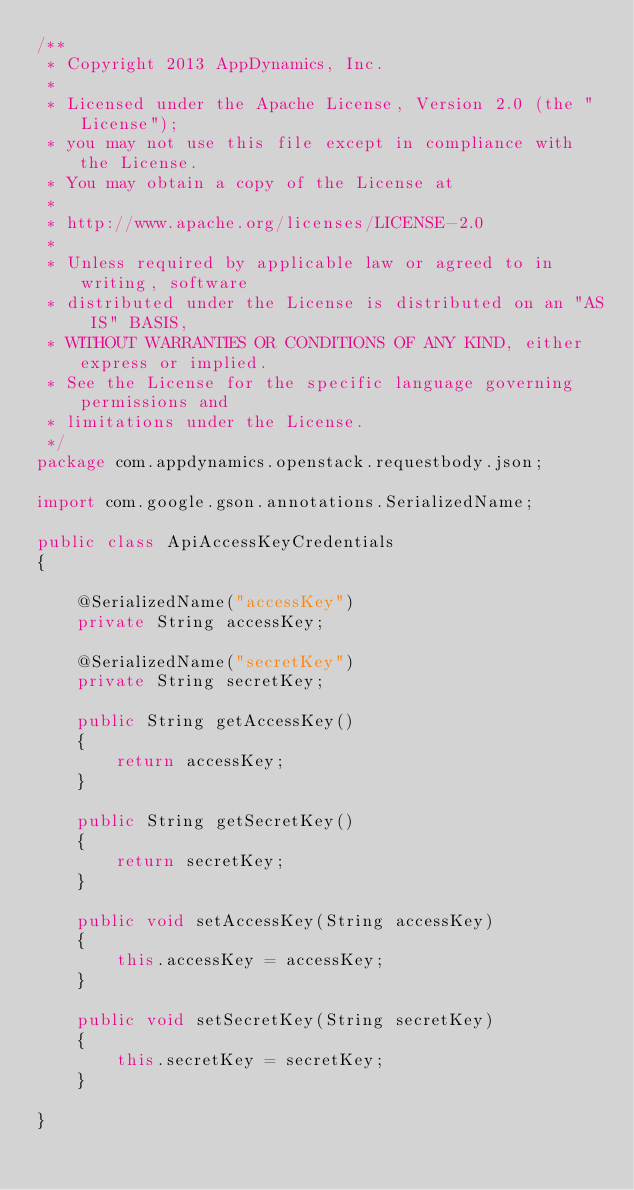<code> <loc_0><loc_0><loc_500><loc_500><_Java_>/**
 * Copyright 2013 AppDynamics, Inc.
 *
 * Licensed under the Apache License, Version 2.0 (the "License");
 * you may not use this file except in compliance with the License.
 * You may obtain a copy of the License at
 *
 * http://www.apache.org/licenses/LICENSE-2.0
 *
 * Unless required by applicable law or agreed to in writing, software
 * distributed under the License is distributed on an "AS IS" BASIS,
 * WITHOUT WARRANTIES OR CONDITIONS OF ANY KIND, either express or implied.
 * See the License for the specific language governing permissions and
 * limitations under the License.
 */
package com.appdynamics.openstack.requestbody.json;

import com.google.gson.annotations.SerializedName;

public class ApiAccessKeyCredentials
{

	@SerializedName("accessKey")
	private String accessKey;
	
	@SerializedName("secretKey")
	private String secretKey;
	
	public String getAccessKey()
	{
		return accessKey;
	}
	
	public String getSecretKey()
	{
		return secretKey;
	}
	
	public void setAccessKey(String accessKey)
	{
		this.accessKey = accessKey;
	}
	
	public void setSecretKey(String secretKey)
	{
		this.secretKey = secretKey;
	}

}
</code> 